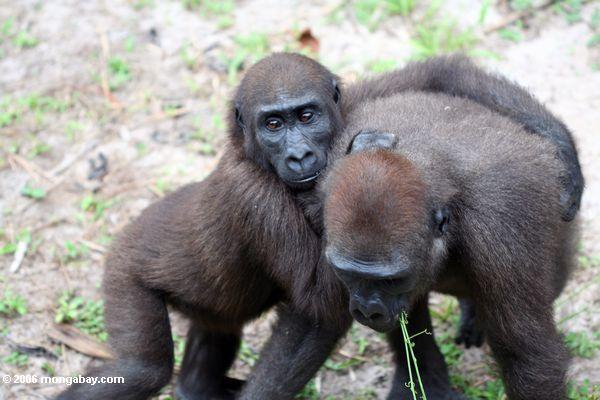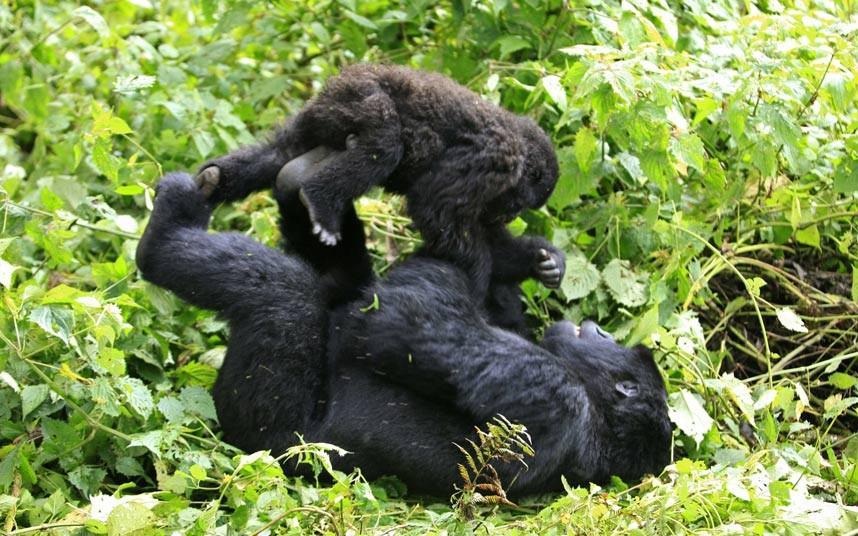The first image is the image on the left, the second image is the image on the right. Analyze the images presented: Is the assertion "On one image, there is a baby gorilla on top of a bigger gorilla." valid? Answer yes or no. Yes. The first image is the image on the left, the second image is the image on the right. Evaluate the accuracy of this statement regarding the images: "There are at most four gorillas.". Is it true? Answer yes or no. Yes. 